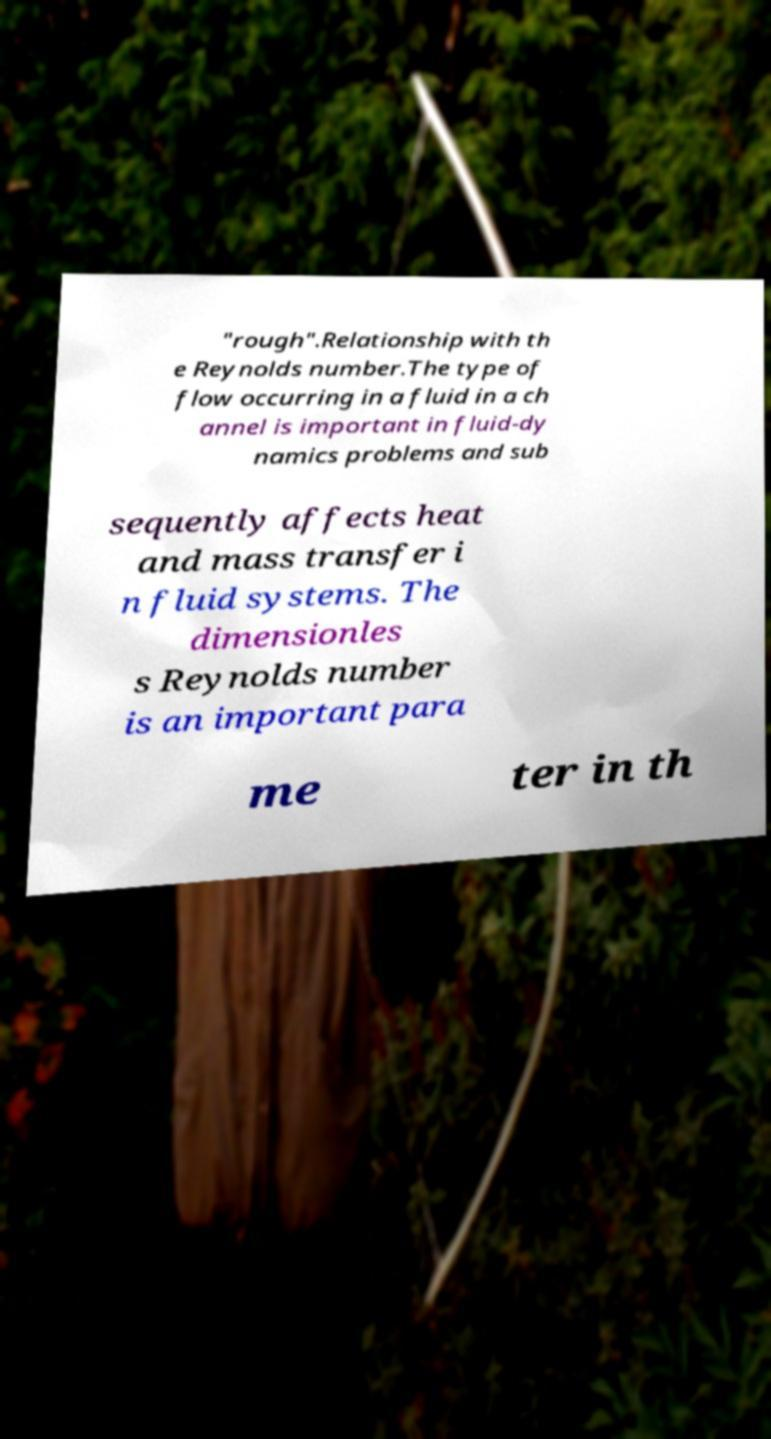What messages or text are displayed in this image? I need them in a readable, typed format. "rough".Relationship with th e Reynolds number.The type of flow occurring in a fluid in a ch annel is important in fluid-dy namics problems and sub sequently affects heat and mass transfer i n fluid systems. The dimensionles s Reynolds number is an important para me ter in th 